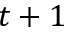<formula> <loc_0><loc_0><loc_500><loc_500>t + 1</formula> 